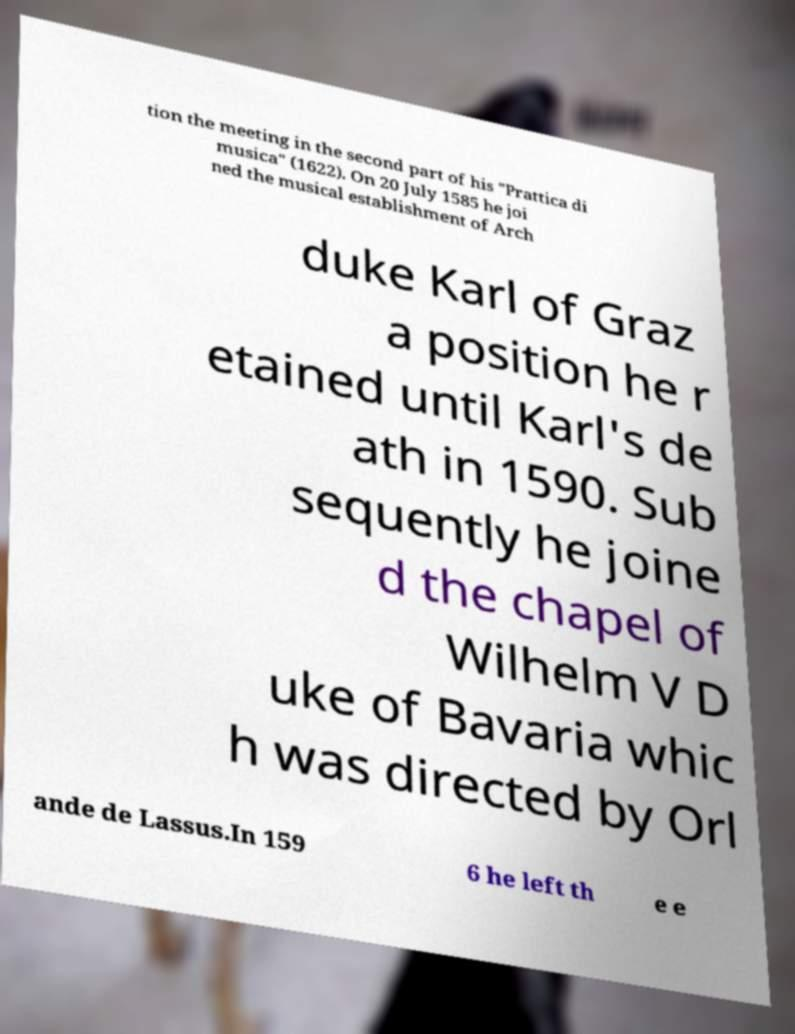Please identify and transcribe the text found in this image. tion the meeting in the second part of his "Prattica di musica" (1622). On 20 July 1585 he joi ned the musical establishment of Arch duke Karl of Graz a position he r etained until Karl's de ath in 1590. Sub sequently he joine d the chapel of Wilhelm V D uke of Bavaria whic h was directed by Orl ande de Lassus.In 159 6 he left th e e 